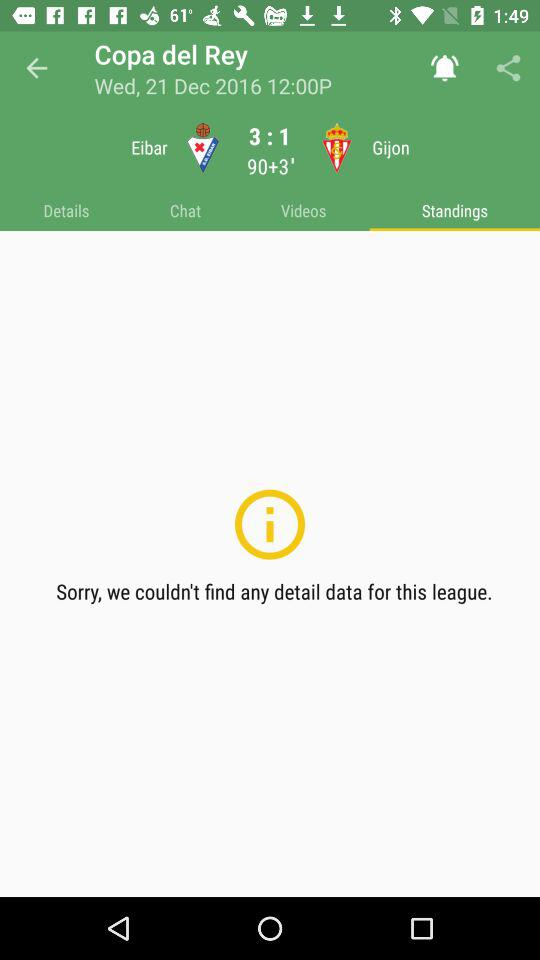What tab has been selected? The selected tab is "Today". 